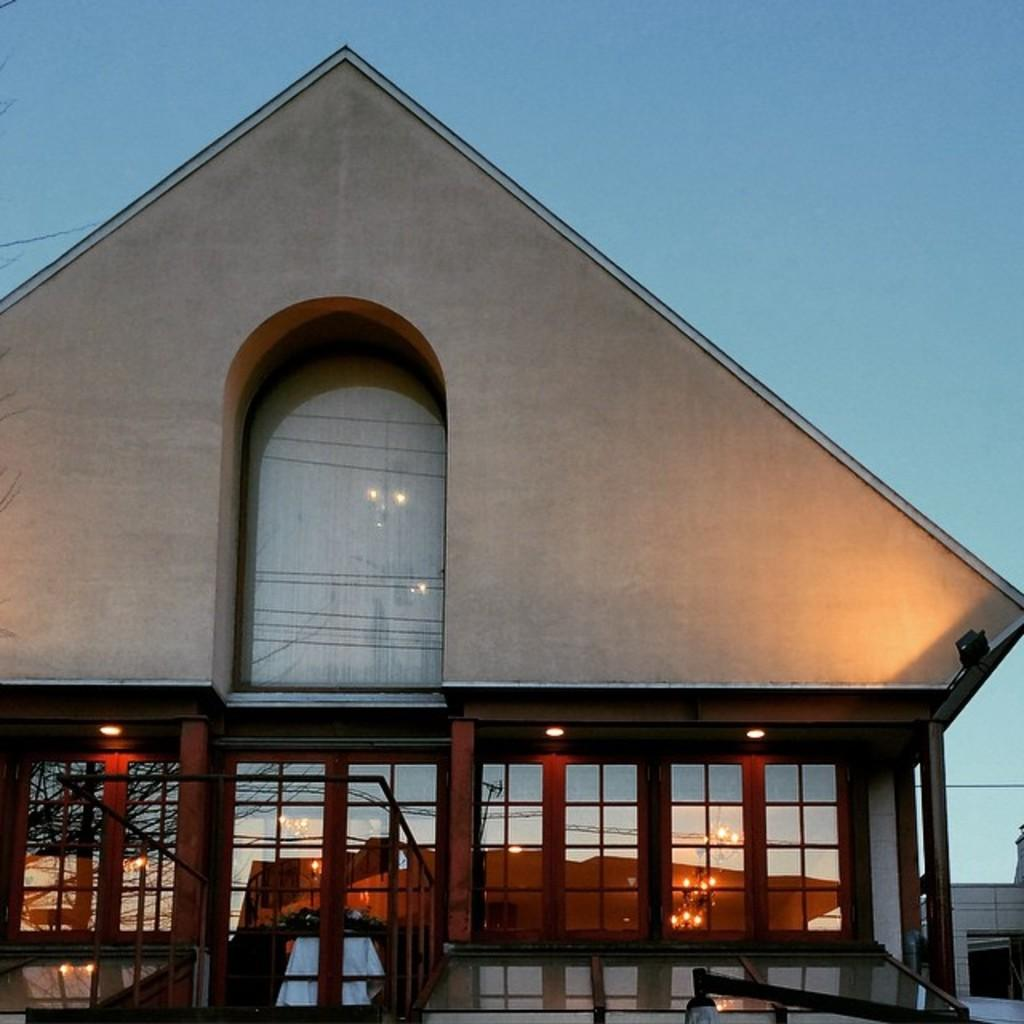What type of structure is present in the image? There is a house in the image. What feature can be seen on the house? The house has glass windows. What else is visible in the image besides the house? There are lights visible in the image. How would you describe the sky in the image? The sky is a combination of white and blue colors. What type of apparel is being worn by the house in the image? There is no apparel present in the image, as the subject is a house and not a person. 